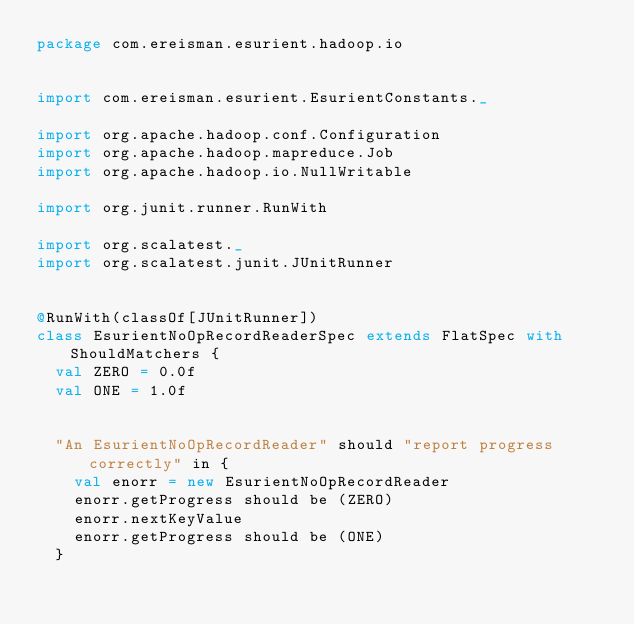<code> <loc_0><loc_0><loc_500><loc_500><_Scala_>package com.ereisman.esurient.hadoop.io


import com.ereisman.esurient.EsurientConstants._

import org.apache.hadoop.conf.Configuration
import org.apache.hadoop.mapreduce.Job
import org.apache.hadoop.io.NullWritable

import org.junit.runner.RunWith

import org.scalatest._
import org.scalatest.junit.JUnitRunner


@RunWith(classOf[JUnitRunner])
class EsurientNoOpRecordReaderSpec extends FlatSpec with ShouldMatchers {
  val ZERO = 0.0f
  val ONE = 1.0f


  "An EsurientNoOpRecordReader" should "report progress correctly" in {
    val enorr = new EsurientNoOpRecordReader
    enorr.getProgress should be (ZERO)
    enorr.nextKeyValue
    enorr.getProgress should be (ONE)
  }
</code> 